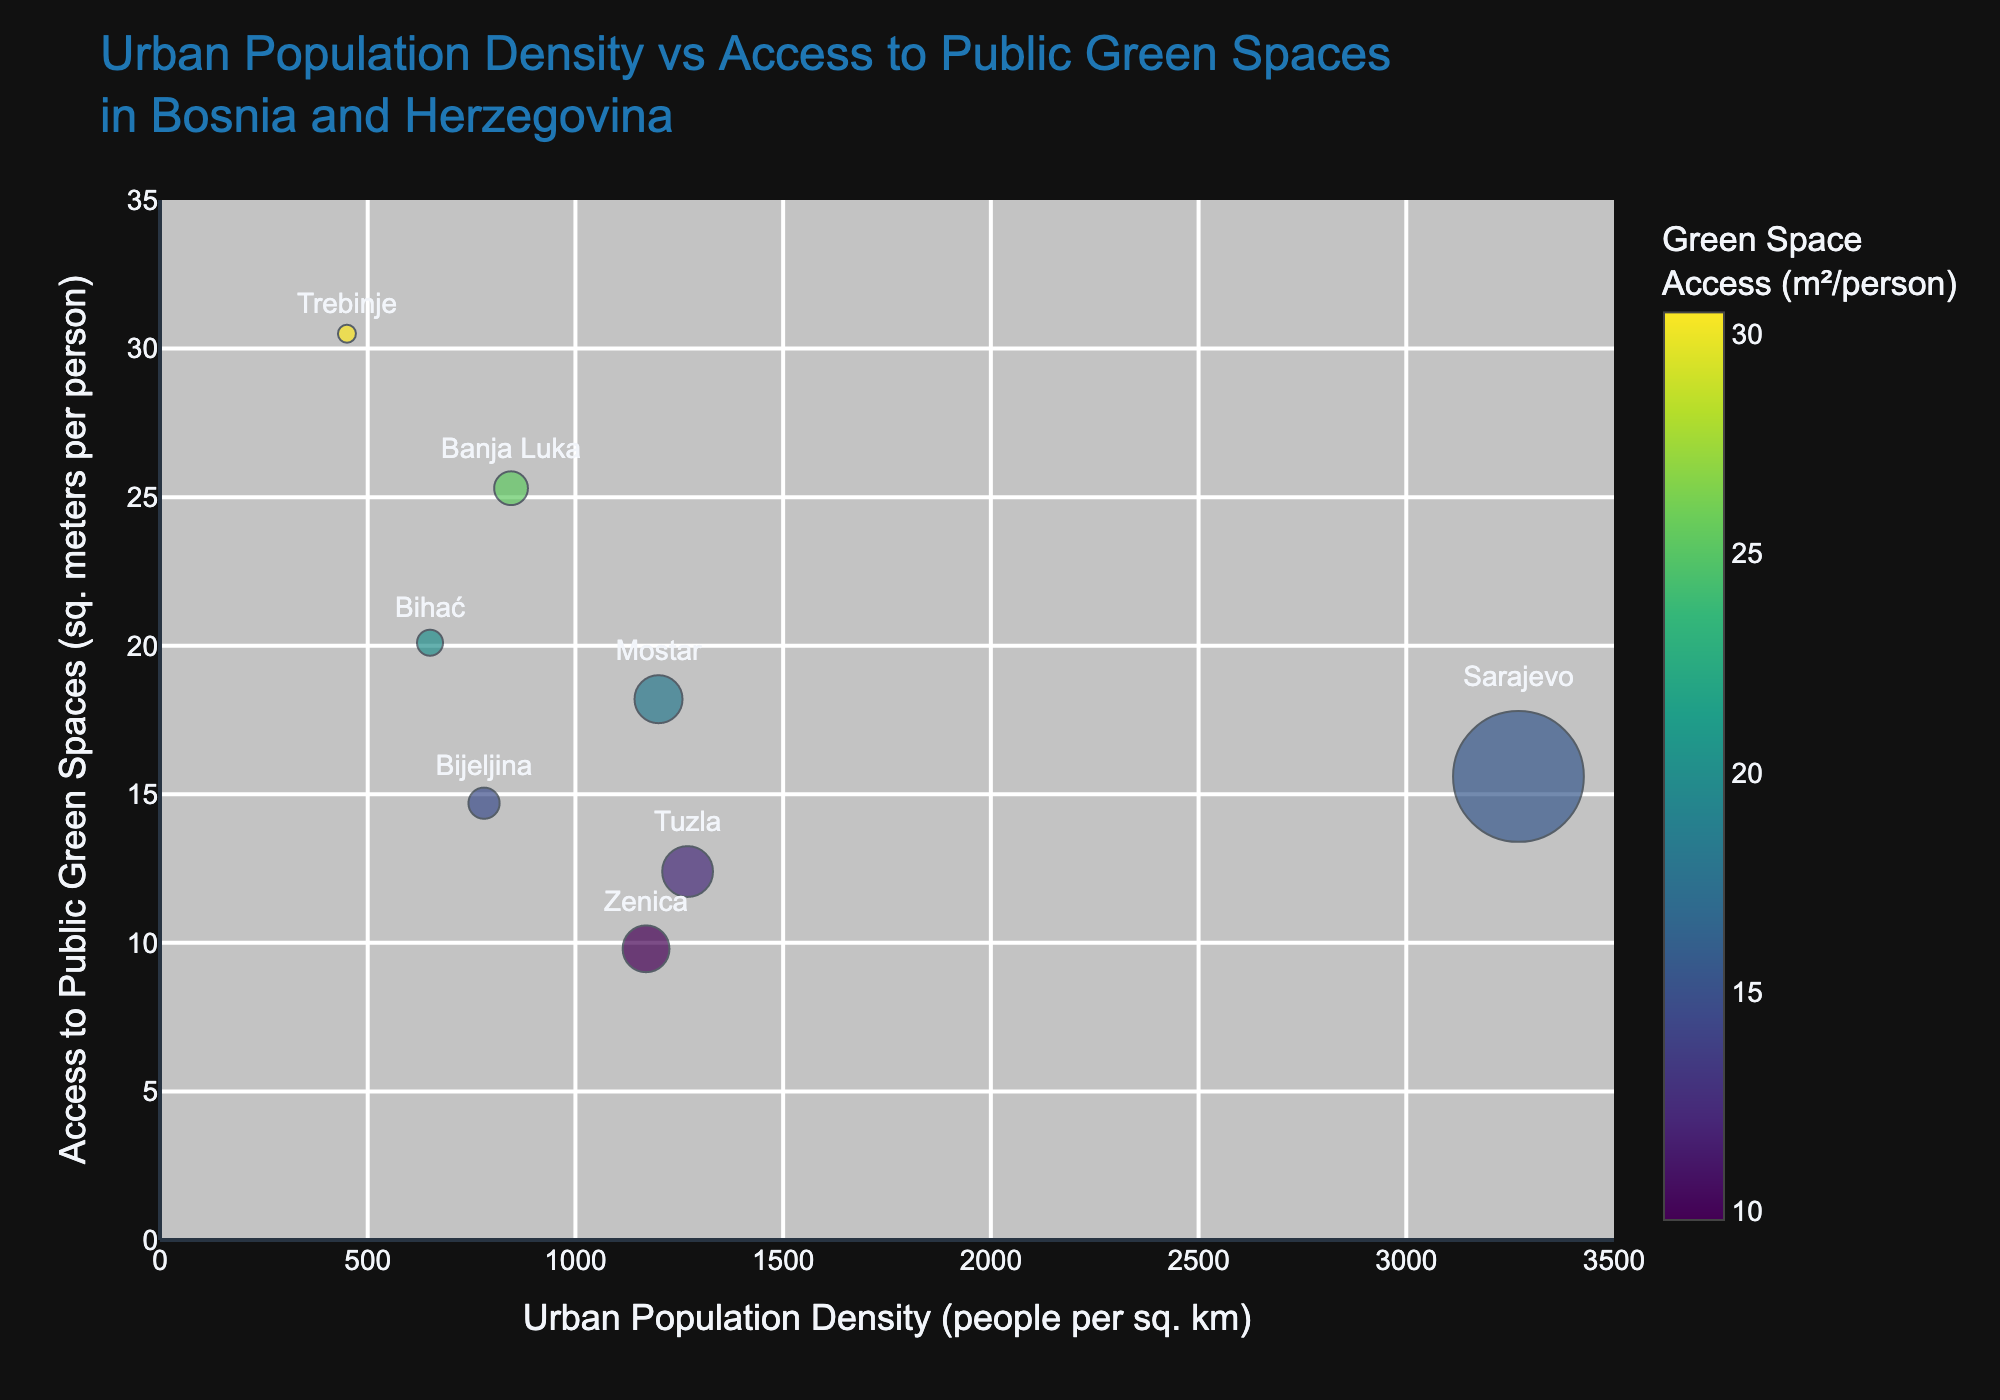What is the title of the figure? The title of the figure is located at the top and describes the main topic of the plot. It is "Urban Population Density vs Access to Public Green Spaces in Bosnia and Herzegovina".
Answer: Urban Population Density vs Access to Public Green Spaces in Bosnia and Herzegovina Which city has the highest urban population density? By looking at the x-axis values, Sarajevo is farthest to the right with a value of 3270. Therefore, Sarajevo has the highest urban population density.
Answer: Sarajevo Which city has the greatest access to public green spaces? By examining the y-axis values, Trebinje is positioned highest at 30.5 square meters per person, indicating it has the greatest access to public green spaces.
Answer: Trebinje What is the average access to public green spaces for Sarajevo and Banja Luka? Access to public green spaces for Sarajevo is 15.6 m²/person and for Banja Luka is 25.3 m²/person. To calculate the average: (15.6 + 25.3) / 2 = 20.45 m²/person.
Answer: 20.45 m²/person Which city has a lower urban population density, Zenica or Mostar? By comparing their x-axis positions, Zenica (1170 people per sq. km) is to the left of Mostar (1200 people per sq. km), indicating Zenica has a lower urban population density.
Answer: Zenica How many cities have more than 20 square meters per person of public green spaces? By identifying all data points above the 20 m² threshold on the y-axis, the cities are Banja Luka, Bihać, and Trebinje, making a total of 3 cities.
Answer: 3 Which city has the smallest access to public green spaces? By looking at the lowest point on the y-axis, Zenica has the smallest access to public green spaces with 9.8 square meters per person.
Answer: Zenica What is the range of urban population density for the cities plotted? The minimum urban population density is Trebinje with 450 people per sq. km, and the maximum is Sarajevo with 3270 people per sq. km. The range is calculated as 3270 - 450 = 2820 people per sq. km.
Answer: 2820 people per sq. km Which city has a higher access to public green spaces, Mostar or Bijeljina? By comparing their y-axis positions, Mostar (18.2 m²/person) is higher than Bijeljina (14.7 m²/person), indicating Mostar has higher access to public green spaces.
Answer: Mostar Is there any city with an urban population density between 1000 and 1300 people per square kilometer? If so, name it. By examining the range from 1000 to 1300 on the x-axis, the cities falling within this range are Tuzla (1270), Zenica (1170), and Mostar (1200).
Answer: Tuzla, Zenica, Mostar 